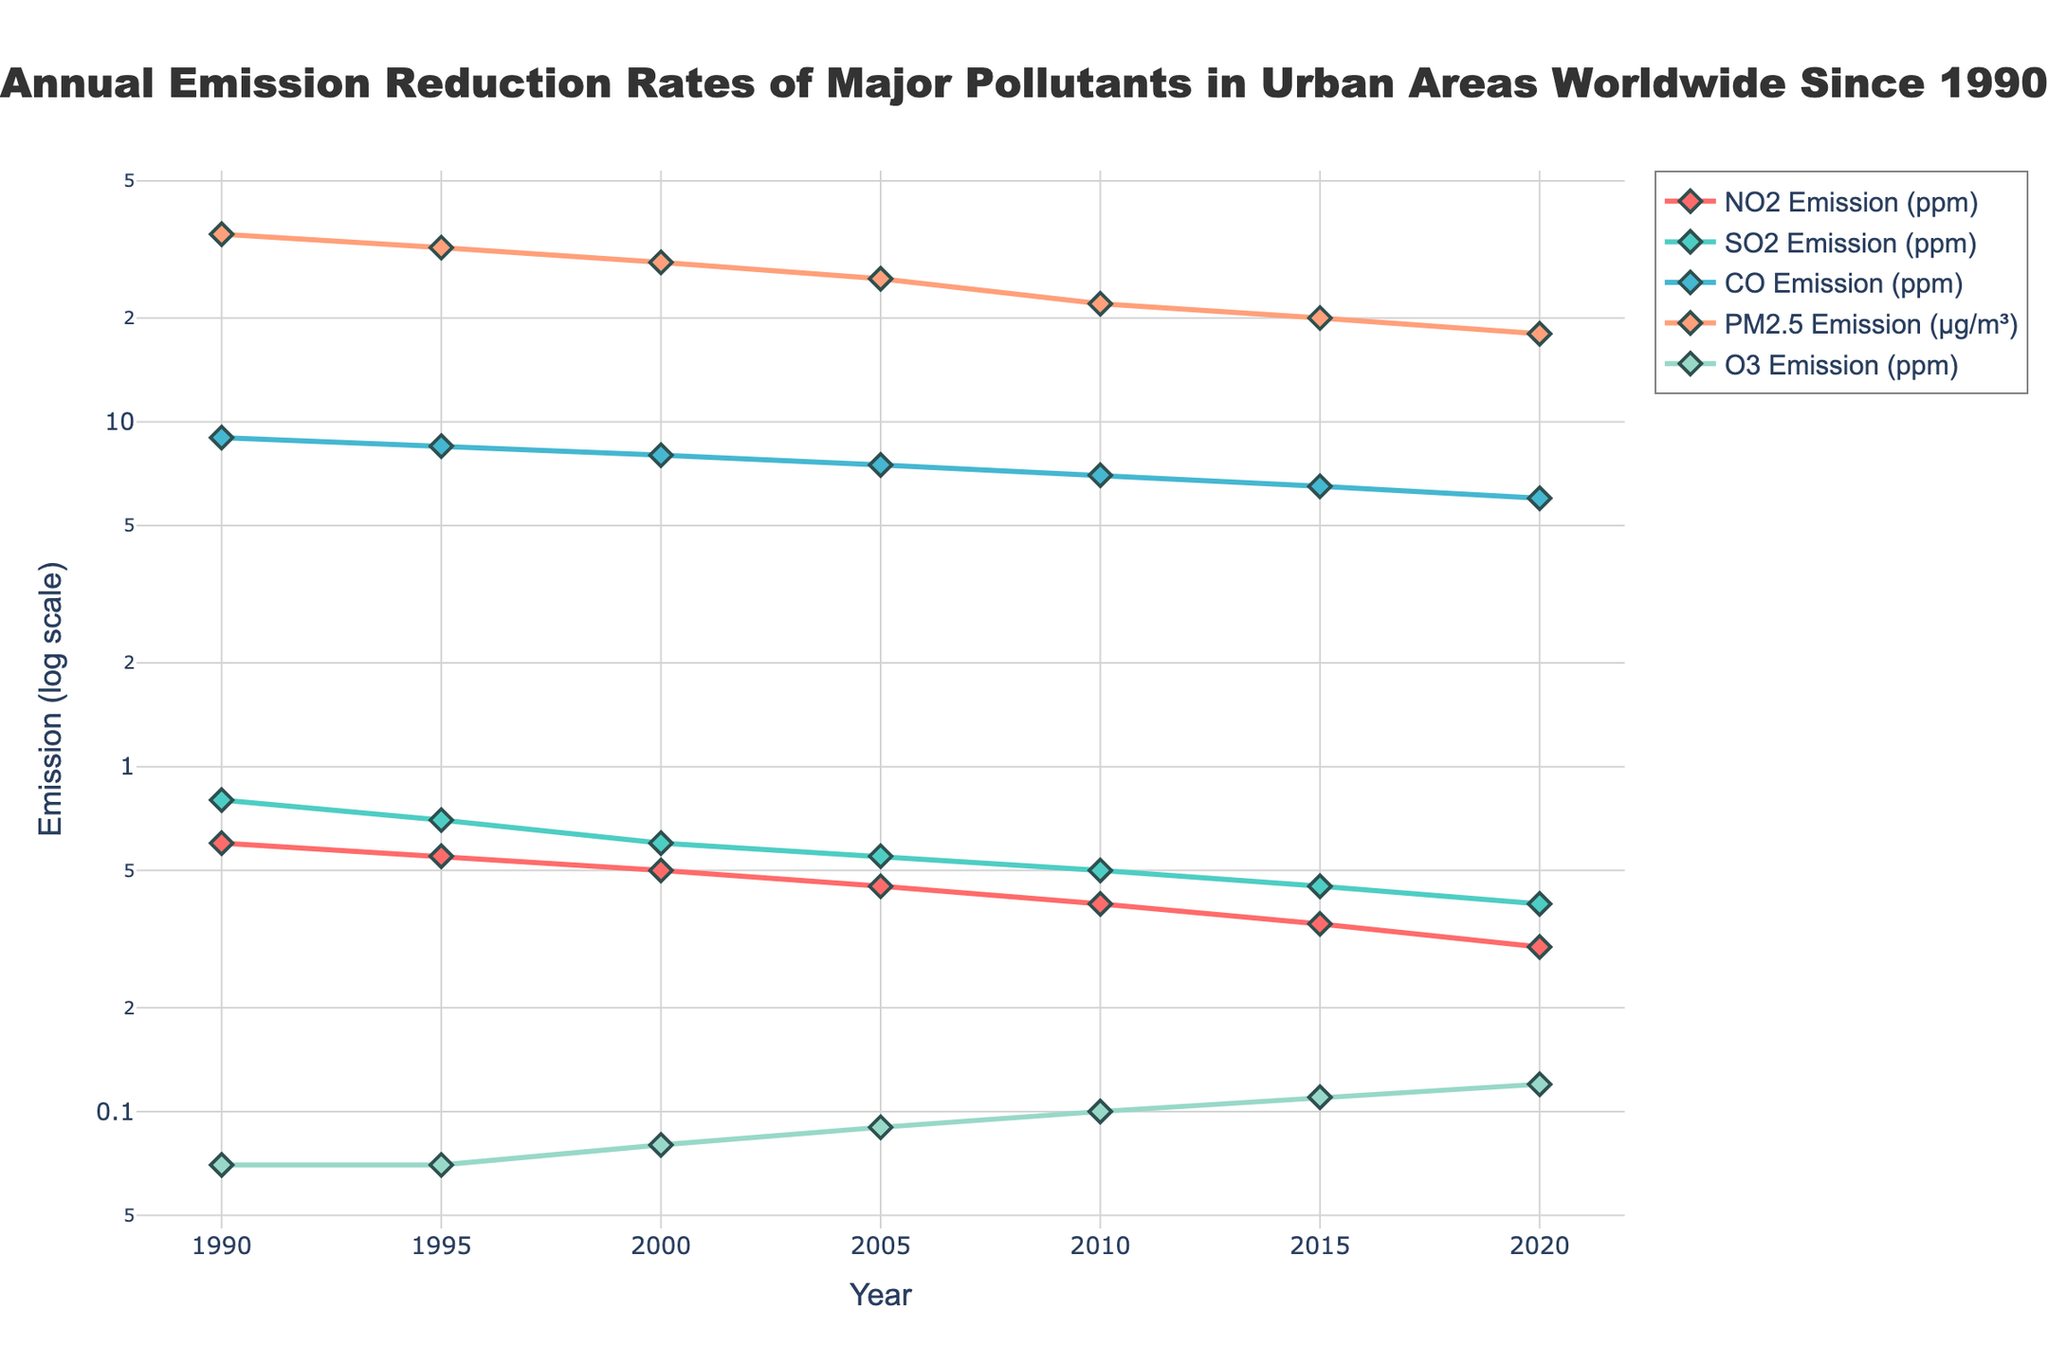What is the title of the figure? The title is located at the top of the figure and is clearly indicated in a larger font.
Answer: Annual Emission Reduction Rates of Major Pollutants in Urban Areas Worldwide Since 1990 What is the range of years covered in this plot? The x-axis represents the years, and the first and last data points on the axis show the range.
Answer: 1990 to 2020 Which pollutant has shown the most significant reduction in emission from 1990 to 2020? By comparing the starting and ending points of each pollutant line, the one with the largest decrease in log-scale emission values indicates the most significant reduction.
Answer: NO2 Emission By how much has the PM2.5 emission decreased from 1990 to 2020? Locate the PM2.5 emission values for 1990 and 2020, and calculate the difference.
Answer: 17 µg/m³ (35 µg/m³ - 18 µg/m³) Which pollutant's emission levels have consistently increased over the years? Look for a trend line that goes upwards from left to right.
Answer: O3 Emission Which pollutant had the highest emission level in 1990? Identify the highest starting point among the lines in 1990.
Answer: CO Emission (9.00 ppm) How many pollutants are tracked in this figure? Count the number of unique pollutant names in the legend or lines in the plot.
Answer: 5 What is the median emission value of CO in 2000? Since there is only one value for CO in 2000, the median is that value.
Answer: 8.00 ppm In which year do all pollutants show a decrease in their values compared to the previous year? Examine each year and compare the values between consecutive years to find when all pollutants are lower than in the preceding year.
Answer: 2015 Which pollutant has the smallest variance in emission values between 1990 and 2020? Identify the line that shows the least change in the y-axis values from the start to the end.
Answer: O3 Emission 